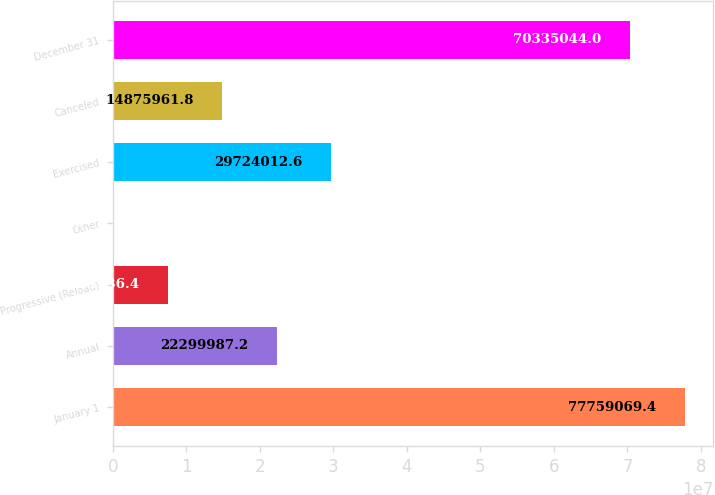<chart> <loc_0><loc_0><loc_500><loc_500><bar_chart><fcel>January 1<fcel>Annual<fcel>Progressive (Reload)<fcel>Other<fcel>Exercised<fcel>Canceled<fcel>December 31<nl><fcel>7.77591e+07<fcel>2.23e+07<fcel>7.45194e+06<fcel>27911<fcel>2.9724e+07<fcel>1.4876e+07<fcel>7.0335e+07<nl></chart> 